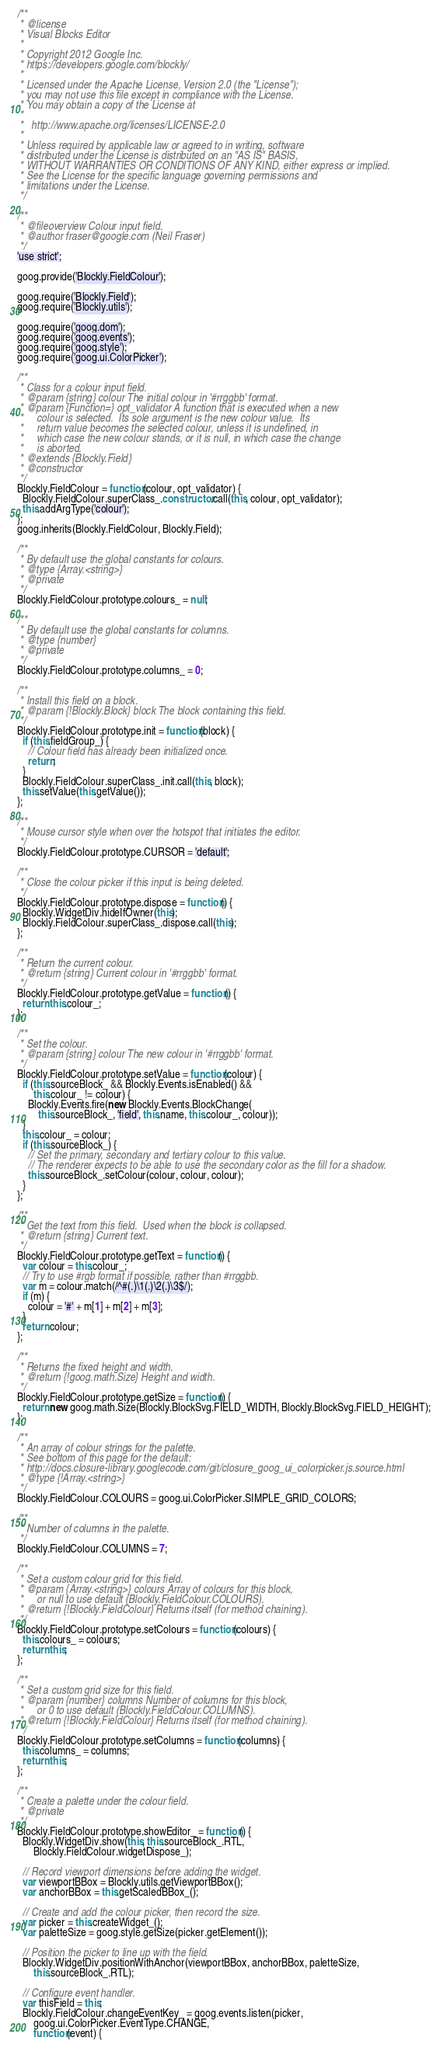Convert code to text. <code><loc_0><loc_0><loc_500><loc_500><_JavaScript_>/**
 * @license
 * Visual Blocks Editor
 *
 * Copyright 2012 Google Inc.
 * https://developers.google.com/blockly/
 *
 * Licensed under the Apache License, Version 2.0 (the "License");
 * you may not use this file except in compliance with the License.
 * You may obtain a copy of the License at
 *
 *   http://www.apache.org/licenses/LICENSE-2.0
 *
 * Unless required by applicable law or agreed to in writing, software
 * distributed under the License is distributed on an "AS IS" BASIS,
 * WITHOUT WARRANTIES OR CONDITIONS OF ANY KIND, either express or implied.
 * See the License for the specific language governing permissions and
 * limitations under the License.
 */

/**
 * @fileoverview Colour input field.
 * @author fraser@google.com (Neil Fraser)
 */
'use strict';

goog.provide('Blockly.FieldColour');

goog.require('Blockly.Field');
goog.require('Blockly.utils');

goog.require('goog.dom');
goog.require('goog.events');
goog.require('goog.style');
goog.require('goog.ui.ColorPicker');

/**
 * Class for a colour input field.
 * @param {string} colour The initial colour in '#rrggbb' format.
 * @param {Function=} opt_validator A function that is executed when a new
 *     colour is selected.  Its sole argument is the new colour value.  Its
 *     return value becomes the selected colour, unless it is undefined, in
 *     which case the new colour stands, or it is null, in which case the change
 *     is aborted.
 * @extends {Blockly.Field}
 * @constructor
 */
Blockly.FieldColour = function(colour, opt_validator) {
  Blockly.FieldColour.superClass_.constructor.call(this, colour, opt_validator);
  this.addArgType('colour');
};
goog.inherits(Blockly.FieldColour, Blockly.Field);

/**
 * By default use the global constants for colours.
 * @type {Array.<string>}
 * @private
 */
Blockly.FieldColour.prototype.colours_ = null;

/**
 * By default use the global constants for columns.
 * @type {number}
 * @private
 */
Blockly.FieldColour.prototype.columns_ = 0;

/**
 * Install this field on a block.
 * @param {!Blockly.Block} block The block containing this field.
 */
Blockly.FieldColour.prototype.init = function(block) {
  if (this.fieldGroup_) {
    // Colour field has already been initialized once.
    return;
  }
  Blockly.FieldColour.superClass_.init.call(this, block);
  this.setValue(this.getValue());
};

/**
 * Mouse cursor style when over the hotspot that initiates the editor.
 */
Blockly.FieldColour.prototype.CURSOR = 'default';

/**
 * Close the colour picker if this input is being deleted.
 */
Blockly.FieldColour.prototype.dispose = function() {
  Blockly.WidgetDiv.hideIfOwner(this);
  Blockly.FieldColour.superClass_.dispose.call(this);
};

/**
 * Return the current colour.
 * @return {string} Current colour in '#rrggbb' format.
 */
Blockly.FieldColour.prototype.getValue = function() {
  return this.colour_;
};

/**
 * Set the colour.
 * @param {string} colour The new colour in '#rrggbb' format.
 */
Blockly.FieldColour.prototype.setValue = function(colour) {
  if (this.sourceBlock_ && Blockly.Events.isEnabled() &&
      this.colour_ != colour) {
    Blockly.Events.fire(new Blockly.Events.BlockChange(
        this.sourceBlock_, 'field', this.name, this.colour_, colour));
  }
  this.colour_ = colour;
  if (this.sourceBlock_) {
    // Set the primary, secondary and tertiary colour to this value.
    // The renderer expects to be able to use the secondary color as the fill for a shadow.
    this.sourceBlock_.setColour(colour, colour, colour);
  }
};

/**
 * Get the text from this field.  Used when the block is collapsed.
 * @return {string} Current text.
 */
Blockly.FieldColour.prototype.getText = function() {
  var colour = this.colour_;
  // Try to use #rgb format if possible, rather than #rrggbb.
  var m = colour.match(/^#(.)\1(.)\2(.)\3$/);
  if (m) {
    colour = '#' + m[1] + m[2] + m[3];
  }
  return colour;
};

/**
 * Returns the fixed height and width.
 * @return {!goog.math.Size} Height and width.
 */
Blockly.FieldColour.prototype.getSize = function() {
  return new goog.math.Size(Blockly.BlockSvg.FIELD_WIDTH, Blockly.BlockSvg.FIELD_HEIGHT);
};

/**
 * An array of colour strings for the palette.
 * See bottom of this page for the default:
 * http://docs.closure-library.googlecode.com/git/closure_goog_ui_colorpicker.js.source.html
 * @type {!Array.<string>}
 */
Blockly.FieldColour.COLOURS = goog.ui.ColorPicker.SIMPLE_GRID_COLORS;

/**
 * Number of columns in the palette.
 */
Blockly.FieldColour.COLUMNS = 7;

/**
 * Set a custom colour grid for this field.
 * @param {Array.<string>} colours Array of colours for this block,
 *     or null to use default (Blockly.FieldColour.COLOURS).
 * @return {!Blockly.FieldColour} Returns itself (for method chaining).
 */
Blockly.FieldColour.prototype.setColours = function(colours) {
  this.colours_ = colours;
  return this;
};

/**
 * Set a custom grid size for this field.
 * @param {number} columns Number of columns for this block,
 *     or 0 to use default (Blockly.FieldColour.COLUMNS).
 * @return {!Blockly.FieldColour} Returns itself (for method chaining).
 */
Blockly.FieldColour.prototype.setColumns = function(columns) {
  this.columns_ = columns;
  return this;
};

/**
 * Create a palette under the colour field.
 * @private
 */
Blockly.FieldColour.prototype.showEditor_ = function() {
  Blockly.WidgetDiv.show(this, this.sourceBlock_.RTL,
      Blockly.FieldColour.widgetDispose_);

  // Record viewport dimensions before adding the widget.
  var viewportBBox = Blockly.utils.getViewportBBox();
  var anchorBBox = this.getScaledBBox_();

  // Create and add the colour picker, then record the size.
  var picker = this.createWidget_();
  var paletteSize = goog.style.getSize(picker.getElement());

  // Position the picker to line up with the field.
  Blockly.WidgetDiv.positionWithAnchor(viewportBBox, anchorBBox, paletteSize,
      this.sourceBlock_.RTL);

  // Configure event handler.
  var thisField = this;
  Blockly.FieldColour.changeEventKey_ = goog.events.listen(picker,
      goog.ui.ColorPicker.EventType.CHANGE,
      function(event) {</code> 